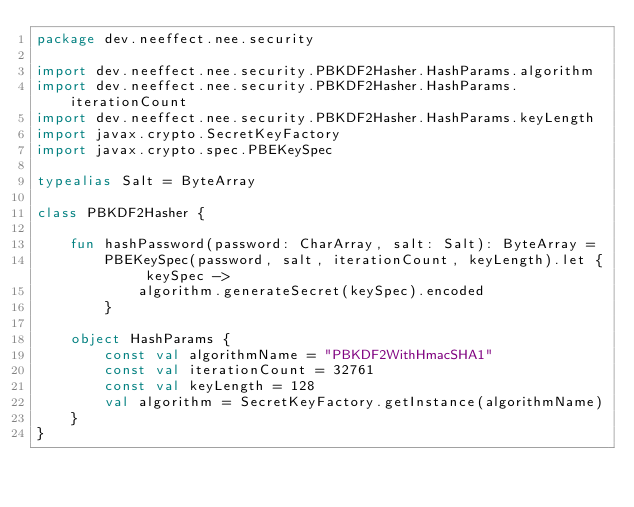<code> <loc_0><loc_0><loc_500><loc_500><_Kotlin_>package dev.neeffect.nee.security

import dev.neeffect.nee.security.PBKDF2Hasher.HashParams.algorithm
import dev.neeffect.nee.security.PBKDF2Hasher.HashParams.iterationCount
import dev.neeffect.nee.security.PBKDF2Hasher.HashParams.keyLength
import javax.crypto.SecretKeyFactory
import javax.crypto.spec.PBEKeySpec

typealias Salt = ByteArray

class PBKDF2Hasher {

    fun hashPassword(password: CharArray, salt: Salt): ByteArray =
        PBEKeySpec(password, salt, iterationCount, keyLength).let { keySpec ->
            algorithm.generateSecret(keySpec).encoded
        }

    object HashParams {
        const val algorithmName = "PBKDF2WithHmacSHA1"
        const val iterationCount = 32761
        const val keyLength = 128
        val algorithm = SecretKeyFactory.getInstance(algorithmName)
    }
}
</code> 